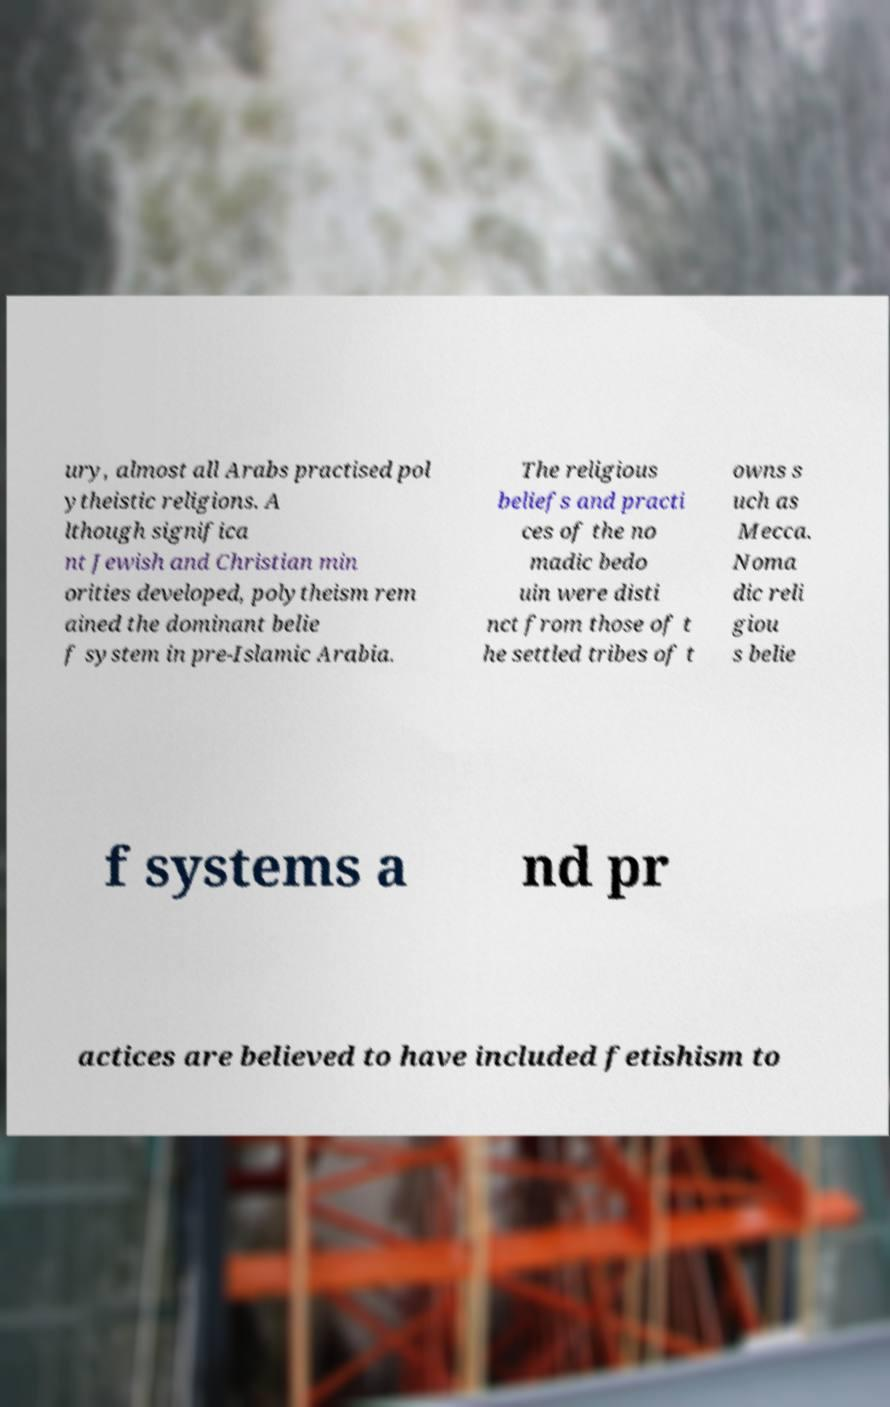For documentation purposes, I need the text within this image transcribed. Could you provide that? ury, almost all Arabs practised pol ytheistic religions. A lthough significa nt Jewish and Christian min orities developed, polytheism rem ained the dominant belie f system in pre-Islamic Arabia. The religious beliefs and practi ces of the no madic bedo uin were disti nct from those of t he settled tribes of t owns s uch as Mecca. Noma dic reli giou s belie f systems a nd pr actices are believed to have included fetishism to 